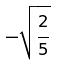<formula> <loc_0><loc_0><loc_500><loc_500>- \sqrt { \frac { 2 } { 5 } }</formula> 